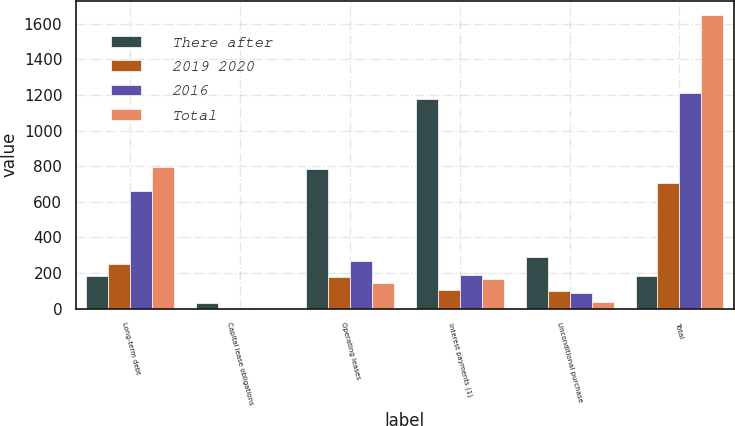Convert chart. <chart><loc_0><loc_0><loc_500><loc_500><stacked_bar_chart><ecel><fcel>Long-term debt<fcel>Capital lease obligations<fcel>Operating leases<fcel>Interest payments (1)<fcel>Unconditional purchase<fcel>Total<nl><fcel>There after<fcel>183.5<fcel>30<fcel>787<fcel>1177<fcel>288<fcel>183.5<nl><fcel>2019 2020<fcel>251<fcel>3<fcel>177<fcel>107<fcel>100<fcel>707<nl><fcel>2016<fcel>662<fcel>6<fcel>266<fcel>190<fcel>89<fcel>1213<nl><fcel>Total<fcel>795<fcel>5<fcel>146<fcel>169<fcel>36<fcel>1647<nl></chart> 